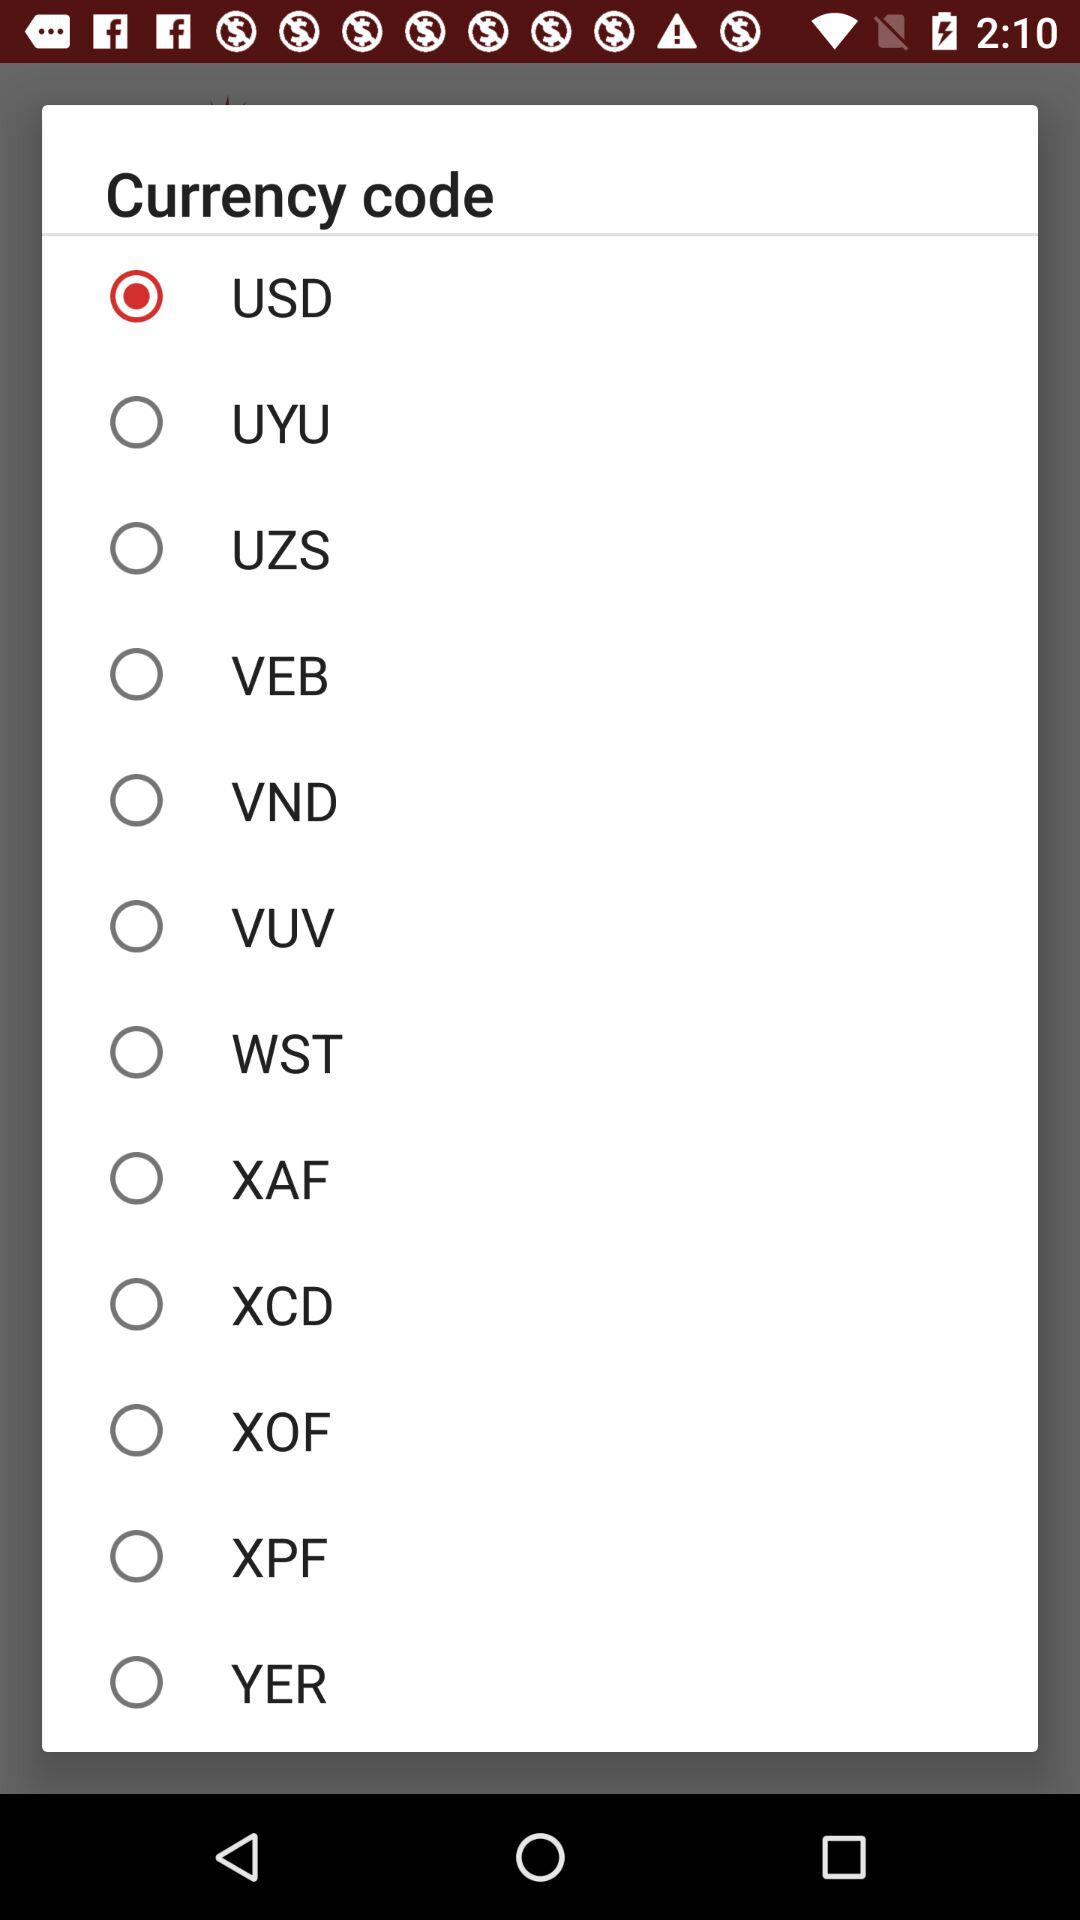What is the name of the application?
When the provided information is insufficient, respond with <no answer>. <no answer> 